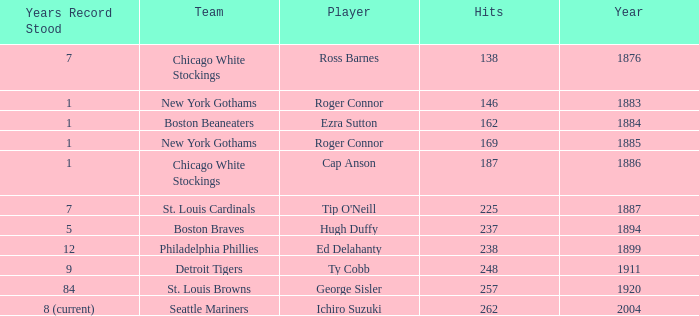Name the player with 238 hits and years after 1885 Ed Delahanty. 